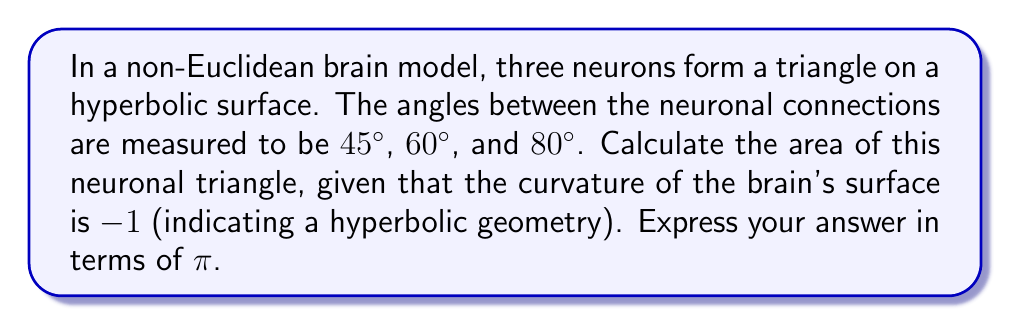Help me with this question. Let's approach this step-by-step:

1) In hyperbolic geometry, the area of a triangle is given by the formula:

   $$A = R^2(\pi - (\alpha + \beta + \gamma))$$

   Where R is the radius of curvature, and α, β, γ are the angles of the triangle.

2) We're given that the curvature is -1. The radius of curvature is the reciprocal of the square root of the absolute value of the curvature. So:

   $$R = \frac{1}{\sqrt{|-1|}} = 1$$

3) We have the angles:
   α = 45° = π/4 radians
   β = 60° = π/3 radians
   γ = 80° = 4π/9 radians

4) Let's sum the angles:

   $$\alpha + \beta + \gamma = \frac{\pi}{4} + \frac{\pi}{3} + \frac{4\pi}{9} = \frac{9\pi}{36} + \frac{12\pi}{36} + \frac{16\pi}{36} = \frac{37\pi}{36}$$

5) Now we can substitute into our area formula:

   $$A = 1^2(\pi - \frac{37\pi}{36}) = \pi - \frac{37\pi}{36} = \frac{36\pi}{36} - \frac{37\pi}{36} = -\frac{\pi}{36}$$

6) The negative sign indicates the opposite orientation, but for area, we take the absolute value.

Therefore, the area of the neuronal triangle is $\frac{\pi}{36}$.
Answer: $\frac{\pi}{36}$ 